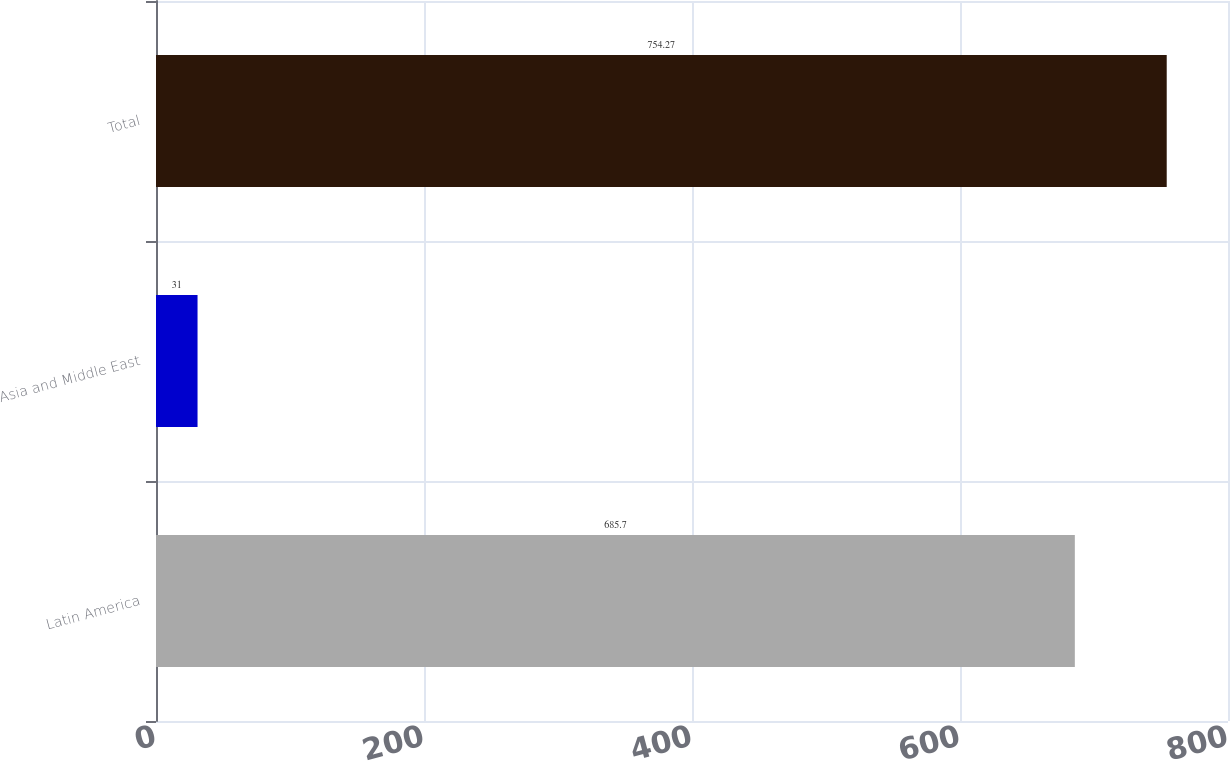Convert chart. <chart><loc_0><loc_0><loc_500><loc_500><bar_chart><fcel>Latin America<fcel>Asia and Middle East<fcel>Total<nl><fcel>685.7<fcel>31<fcel>754.27<nl></chart> 